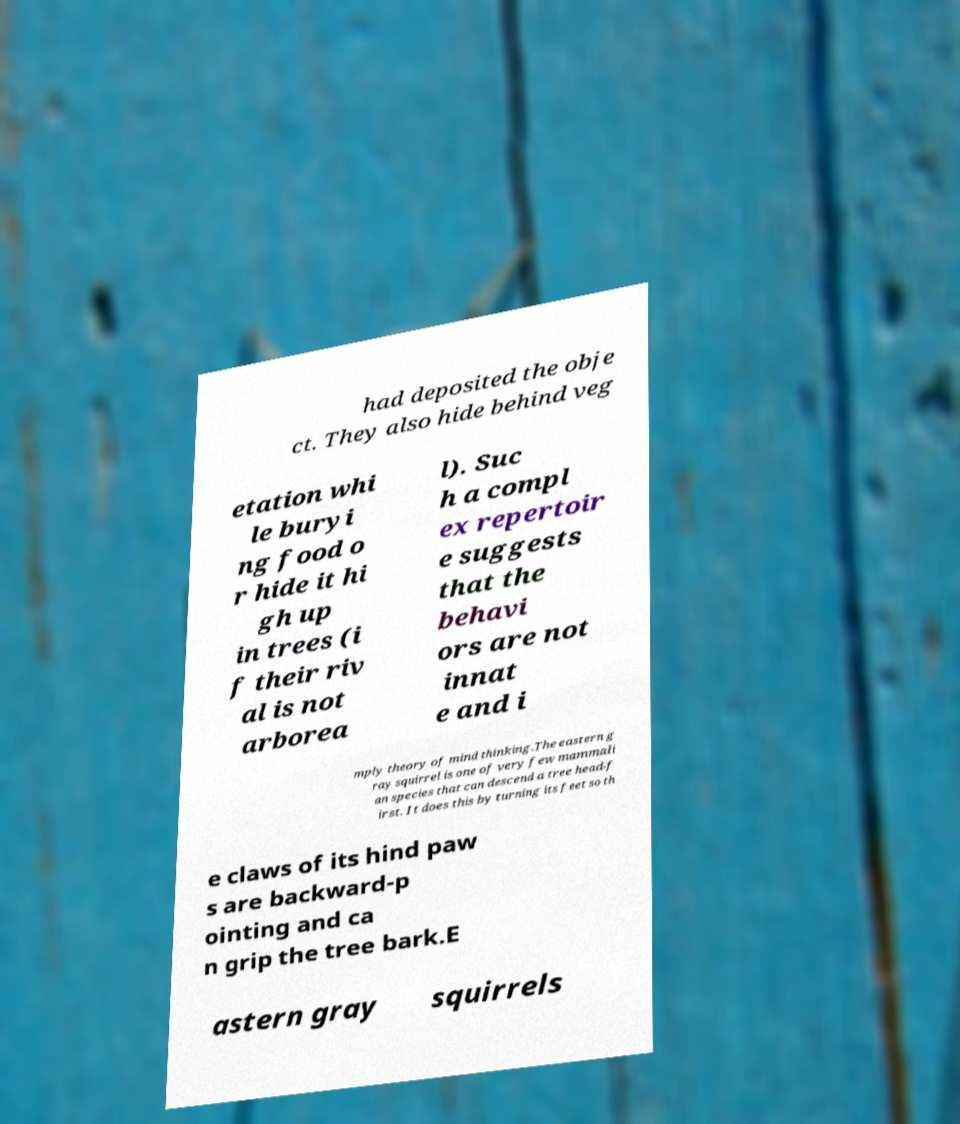I need the written content from this picture converted into text. Can you do that? had deposited the obje ct. They also hide behind veg etation whi le buryi ng food o r hide it hi gh up in trees (i f their riv al is not arborea l). Suc h a compl ex repertoir e suggests that the behavi ors are not innat e and i mply theory of mind thinking.The eastern g ray squirrel is one of very few mammali an species that can descend a tree head-f irst. It does this by turning its feet so th e claws of its hind paw s are backward-p ointing and ca n grip the tree bark.E astern gray squirrels 